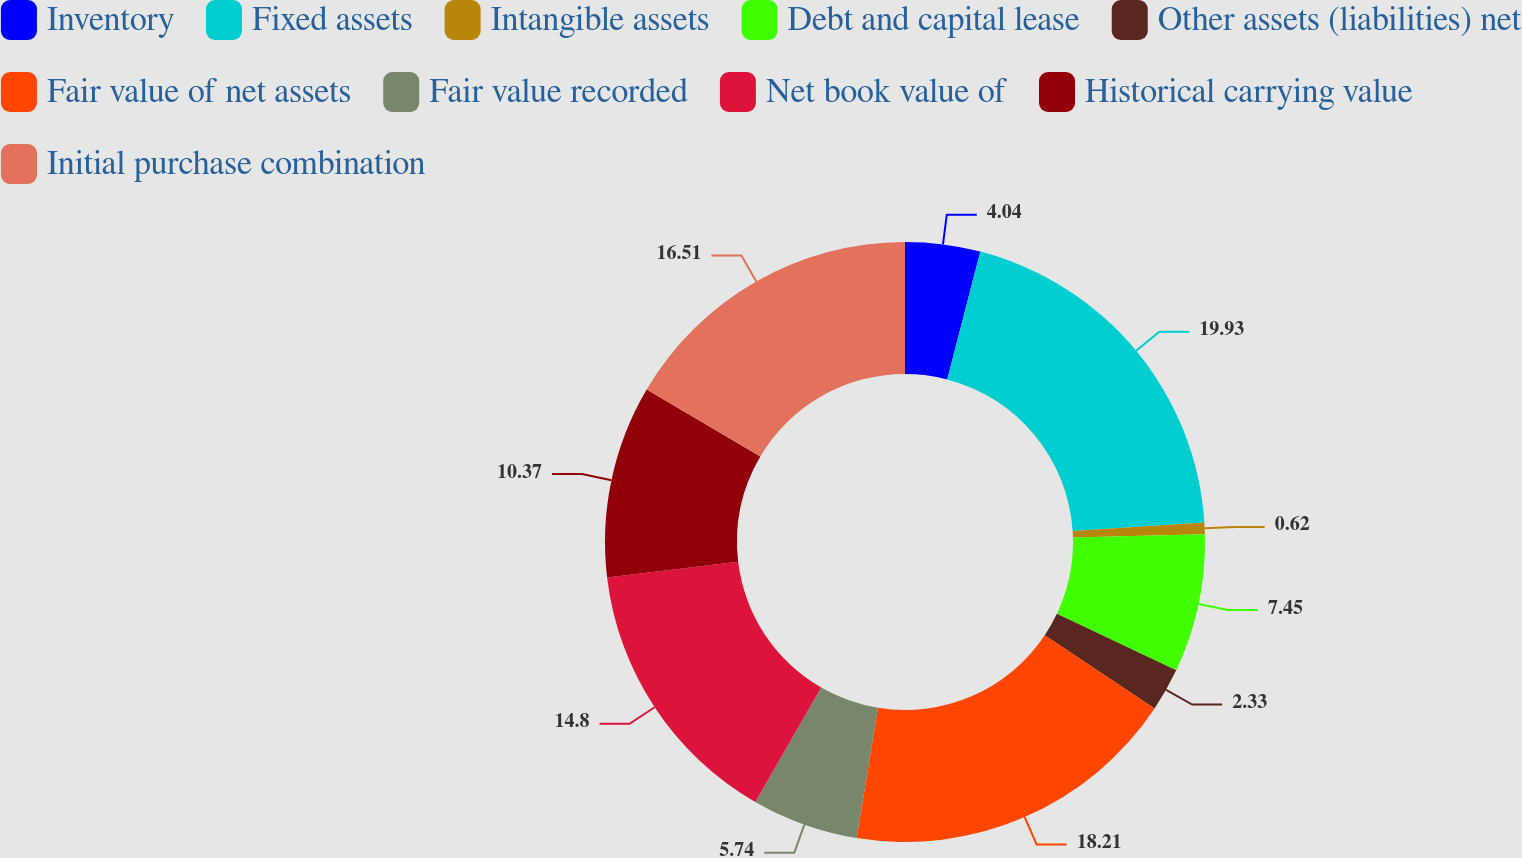Convert chart to OTSL. <chart><loc_0><loc_0><loc_500><loc_500><pie_chart><fcel>Inventory<fcel>Fixed assets<fcel>Intangible assets<fcel>Debt and capital lease<fcel>Other assets (liabilities) net<fcel>Fair value of net assets<fcel>Fair value recorded<fcel>Net book value of<fcel>Historical carrying value<fcel>Initial purchase combination<nl><fcel>4.04%<fcel>19.92%<fcel>0.62%<fcel>7.45%<fcel>2.33%<fcel>18.21%<fcel>5.74%<fcel>14.8%<fcel>10.37%<fcel>16.51%<nl></chart> 